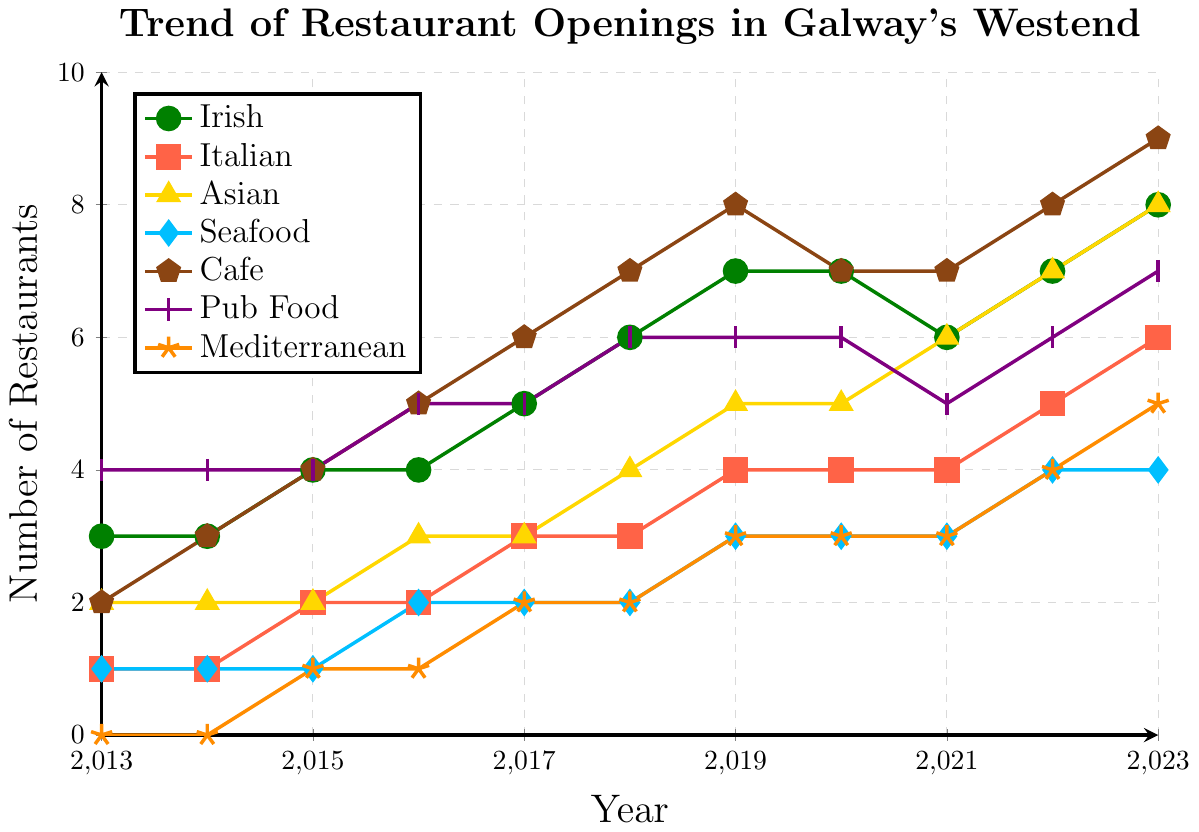Which cuisine saw the highest increase in the number of restaurants from 2013 to 2023? To determine which cuisine saw the highest increase, subtract the number of restaurants in 2013 from the number in 2023 for each cuisine: Irish (8-3=5), Italian (6-1=5), Asian (8-2=6), Seafood (4-1=3), Cafe (9-2=7), Pub Food (7-4=3), Mediterranean (5-0=5). The highest increase is for Cafe with an increase of 7.
Answer: Cafe Which year saw the highest number of new Irish restaurants compared to the previous year? To find the largest increase in a single year, compare the number of Irish restaurants each year to the year before: 2014 (3-3=0), 2015 (4-3=1), 2016 (4-4=0), 2017 (5-4=1), 2018 (6-5=1), 2019 (7-6=1), 2020 (7-7=0), 2021 (6-7=-1), 2022 (7-6=1), 2023 (8-7=1). No year stands out with a change greater than 1.
Answer: No significant year How many Mediterranean restaurants were there in 2018 compared to the total number of restaurants of any type in that year? Sum the total number of all types of restaurants in 2018: Irish (6), Italian (3), Asian (4), Seafood (2), Cafe (7), Pub Food (6), Mediterranean (2). Total = 6+3+4+2+7+6+2 = 30. Mediterranean makes up (2/30)*100 = 6.67%.
Answer: 6.67% Did the number of Seafood restaurants ever decrease between any two consecutive years? Check each year's number of Seafood restaurants compared to the previous year: 2014 (1-1=0), 2015 (1-1=0), 2016 (2-1=1), 2017 (2-2=0), 2018 (2-2=0), 2019 (3-2=1), 2020 (3-3=0), 2021 (3-3=0), 2022 (4-3=1), 2023 (4-4=0). There are no decreases.
Answer: No Which two types of cuisine had the closest number of restaurants in 2019? Compare 2019 restaurant numbers for each pair: Irish (7), Italian (4), Asian (5), Seafood (3), Cafe (8), Pub Food (6), Mediterranean (3). The closest pair is Italian (4) and Pub Food (6) with a difference of 2, and Seafood (3) and Mediterranean (3) with a difference of 0.
Answer: Seafood and Mediterranean How many years did the number of Pub Food restaurants remain constant? Track the number across the years: 2013 (4), 2014 (4), 2015 (4), 2016 (5), 2017 (5), 2018 (6), 2019 (6), 2020 (6), 2021 (5), 2022 (6), 2023 (7). The number remained constant in years 2013-2015 (3 years), 2017-2019 (3 years), making a total of 6 years.
Answer: 6 Which cuisine had exactly 3 restaurants in the year 2017? Look at the 2017 data: Irish (5), Italian (3), Asian (3), Seafood (2), Cafe (6), Pub Food (5), Mediterranean (2). Both Italian and Asian had exactly 3 restaurants.
Answer: Italian, Asian 